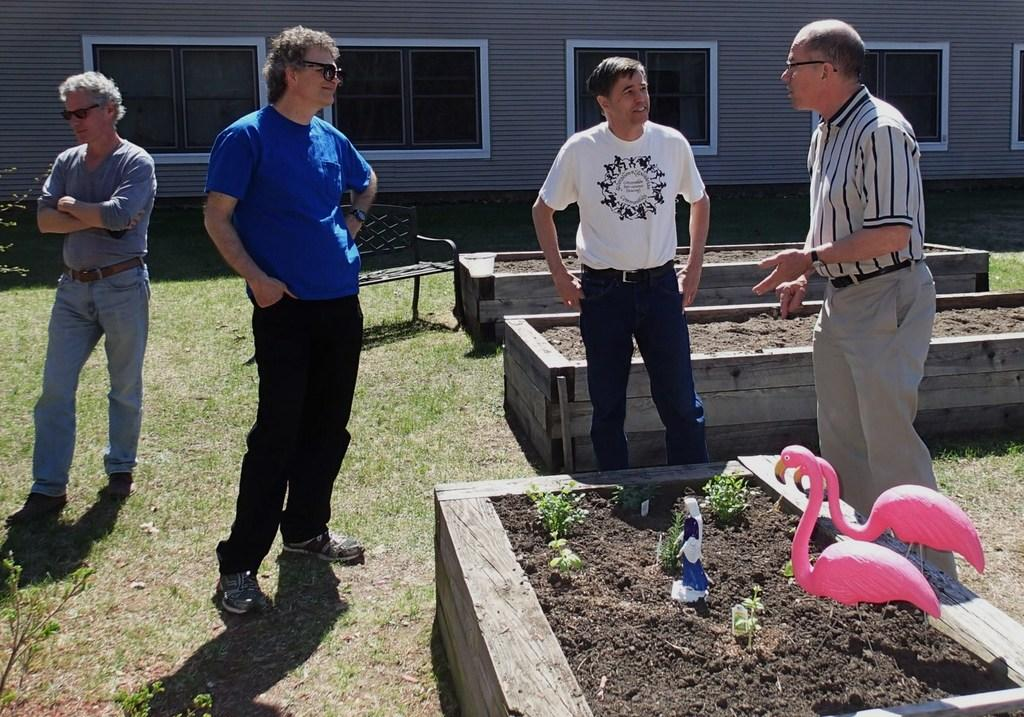How many people are in the image? There are four people on the ground in the image. What else can be seen in the image besides the people? There is a chair, toys, plants, soil, wooden objects, a wall, and windows visible in the image. What type of objects are made of wood? Wooden objects are in the image. What is visible in the background of the image? There is a wall and windows visible in the background of the image. What type of oven is being used to cook the food in the image? There is no oven present in the image. What is the thumb of the person in the image doing? There is no thumb visible in the image, as it is not possible to see individual fingers or body parts of the people in the image. 